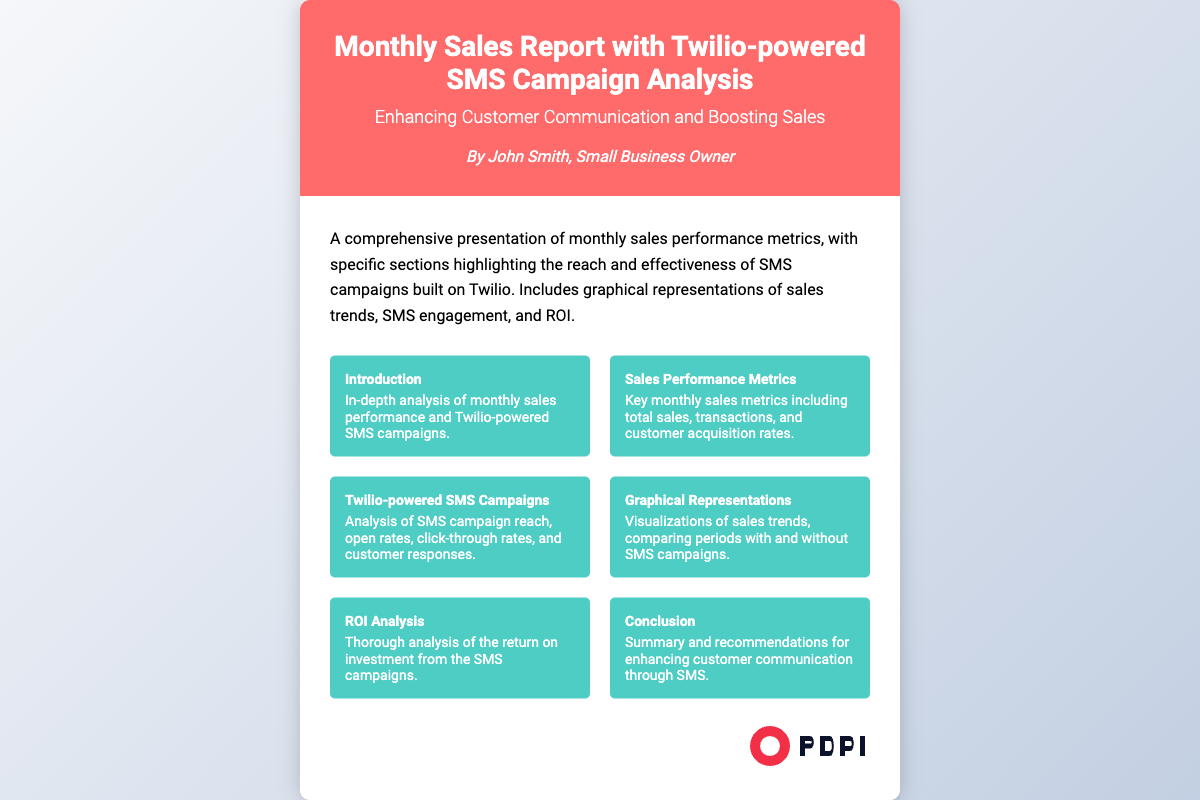what is the title of the document? The title of the document is mentioned in the header section.
Answer: Monthly Sales Report with Twilio-powered SMS Campaign Analysis who is the author of the document? The author is listed below the subtitle in the header section.
Answer: John Smith what is the main focus of the document? The description section explains the document's purpose and focus.
Answer: Monthly sales performance metrics and SMS campaign analysis how many sections are listed in the document? The total number of sections is provided in the content area, summarized in the sections grid.
Answer: Six what color is the header background? The header section's background color is specified in the style section.
Answer: Red what is the subtitle of the document? The subtitle is located in the header, directly below the title.
Answer: Enhancing Customer Communication and Boosting Sales which section contains ROI analysis? The specific section addressing return on investment is named explicitly in the sections grid.
Answer: ROI Analysis what type of graphical representations are included in the document? The document mentions visualizations related to sales trends and SMS campaigns.
Answer: Sales trends and SMS engagement what is the primary tool used for SMS campaigns in the document? The document emphasizes the utilization of a specific platform for SMS communication.
Answer: Twilio 